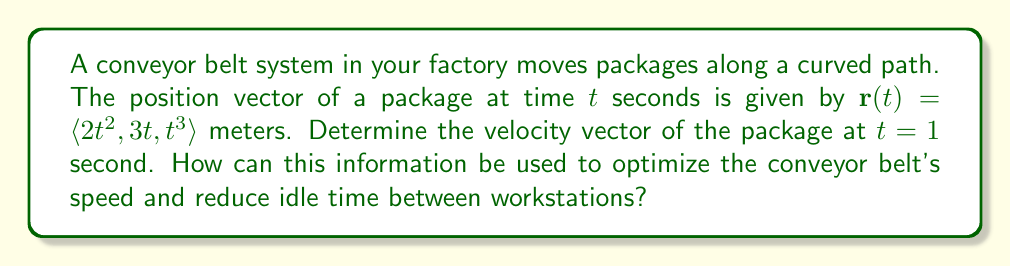Give your solution to this math problem. To solve this problem, we need to follow these steps:

1) The velocity vector is the first derivative of the position vector with respect to time. We can find this by differentiating each component of $\mathbf{r}(t)$.

   $\mathbf{v}(t) = \frac{d}{dt}\mathbf{r}(t) = \langle \frac{d}{dt}(2t^2), \frac{d}{dt}(3t), \frac{d}{dt}(t^3) \rangle$

2) Let's differentiate each component:
   
   $\frac{d}{dt}(2t^2) = 4t$
   $\frac{d}{dt}(3t) = 3$
   $\frac{d}{dt}(t^3) = 3t^2$

3) Therefore, the velocity vector is:

   $\mathbf{v}(t) = \langle 4t, 3, 3t^2 \rangle$

4) To find the velocity at $t = 1$ second, we substitute $t = 1$ into this expression:

   $\mathbf{v}(1) = \langle 4(1), 3, 3(1)^2 \rangle = \langle 4, 3, 3 \rangle$

This velocity vector tells us the speed and direction of the package at $t = 1$ second. The magnitude of this vector (which can be calculated using the Pythagorean theorem) would give the speed of the package.

To optimize the conveyor belt's speed and reduce idle time:

1) We can adjust the belt speed based on this velocity to ensure packages arrive at workstations at the optimal rate.
2) By understanding the velocity at different points, we can identify where packages might be moving too quickly or slowly, allowing us to make adjustments to the belt's speed or curvature.
3) This information can help in spacing workstations appropriately along the belt to minimize idle time between package arrivals.
Answer: The velocity vector of the package at $t = 1$ second is $\mathbf{v}(1) = \langle 4, 3, 3 \rangle$ meters per second. 